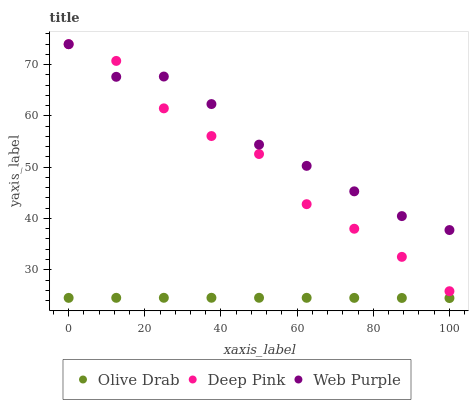Does Olive Drab have the minimum area under the curve?
Answer yes or no. Yes. Does Web Purple have the maximum area under the curve?
Answer yes or no. Yes. Does Deep Pink have the minimum area under the curve?
Answer yes or no. No. Does Deep Pink have the maximum area under the curve?
Answer yes or no. No. Is Olive Drab the smoothest?
Answer yes or no. Yes. Is Deep Pink the roughest?
Answer yes or no. Yes. Is Deep Pink the smoothest?
Answer yes or no. No. Is Olive Drab the roughest?
Answer yes or no. No. Does Olive Drab have the lowest value?
Answer yes or no. Yes. Does Deep Pink have the lowest value?
Answer yes or no. No. Does Deep Pink have the highest value?
Answer yes or no. Yes. Does Olive Drab have the highest value?
Answer yes or no. No. Is Olive Drab less than Deep Pink?
Answer yes or no. Yes. Is Deep Pink greater than Olive Drab?
Answer yes or no. Yes. Does Web Purple intersect Deep Pink?
Answer yes or no. Yes. Is Web Purple less than Deep Pink?
Answer yes or no. No. Is Web Purple greater than Deep Pink?
Answer yes or no. No. Does Olive Drab intersect Deep Pink?
Answer yes or no. No. 